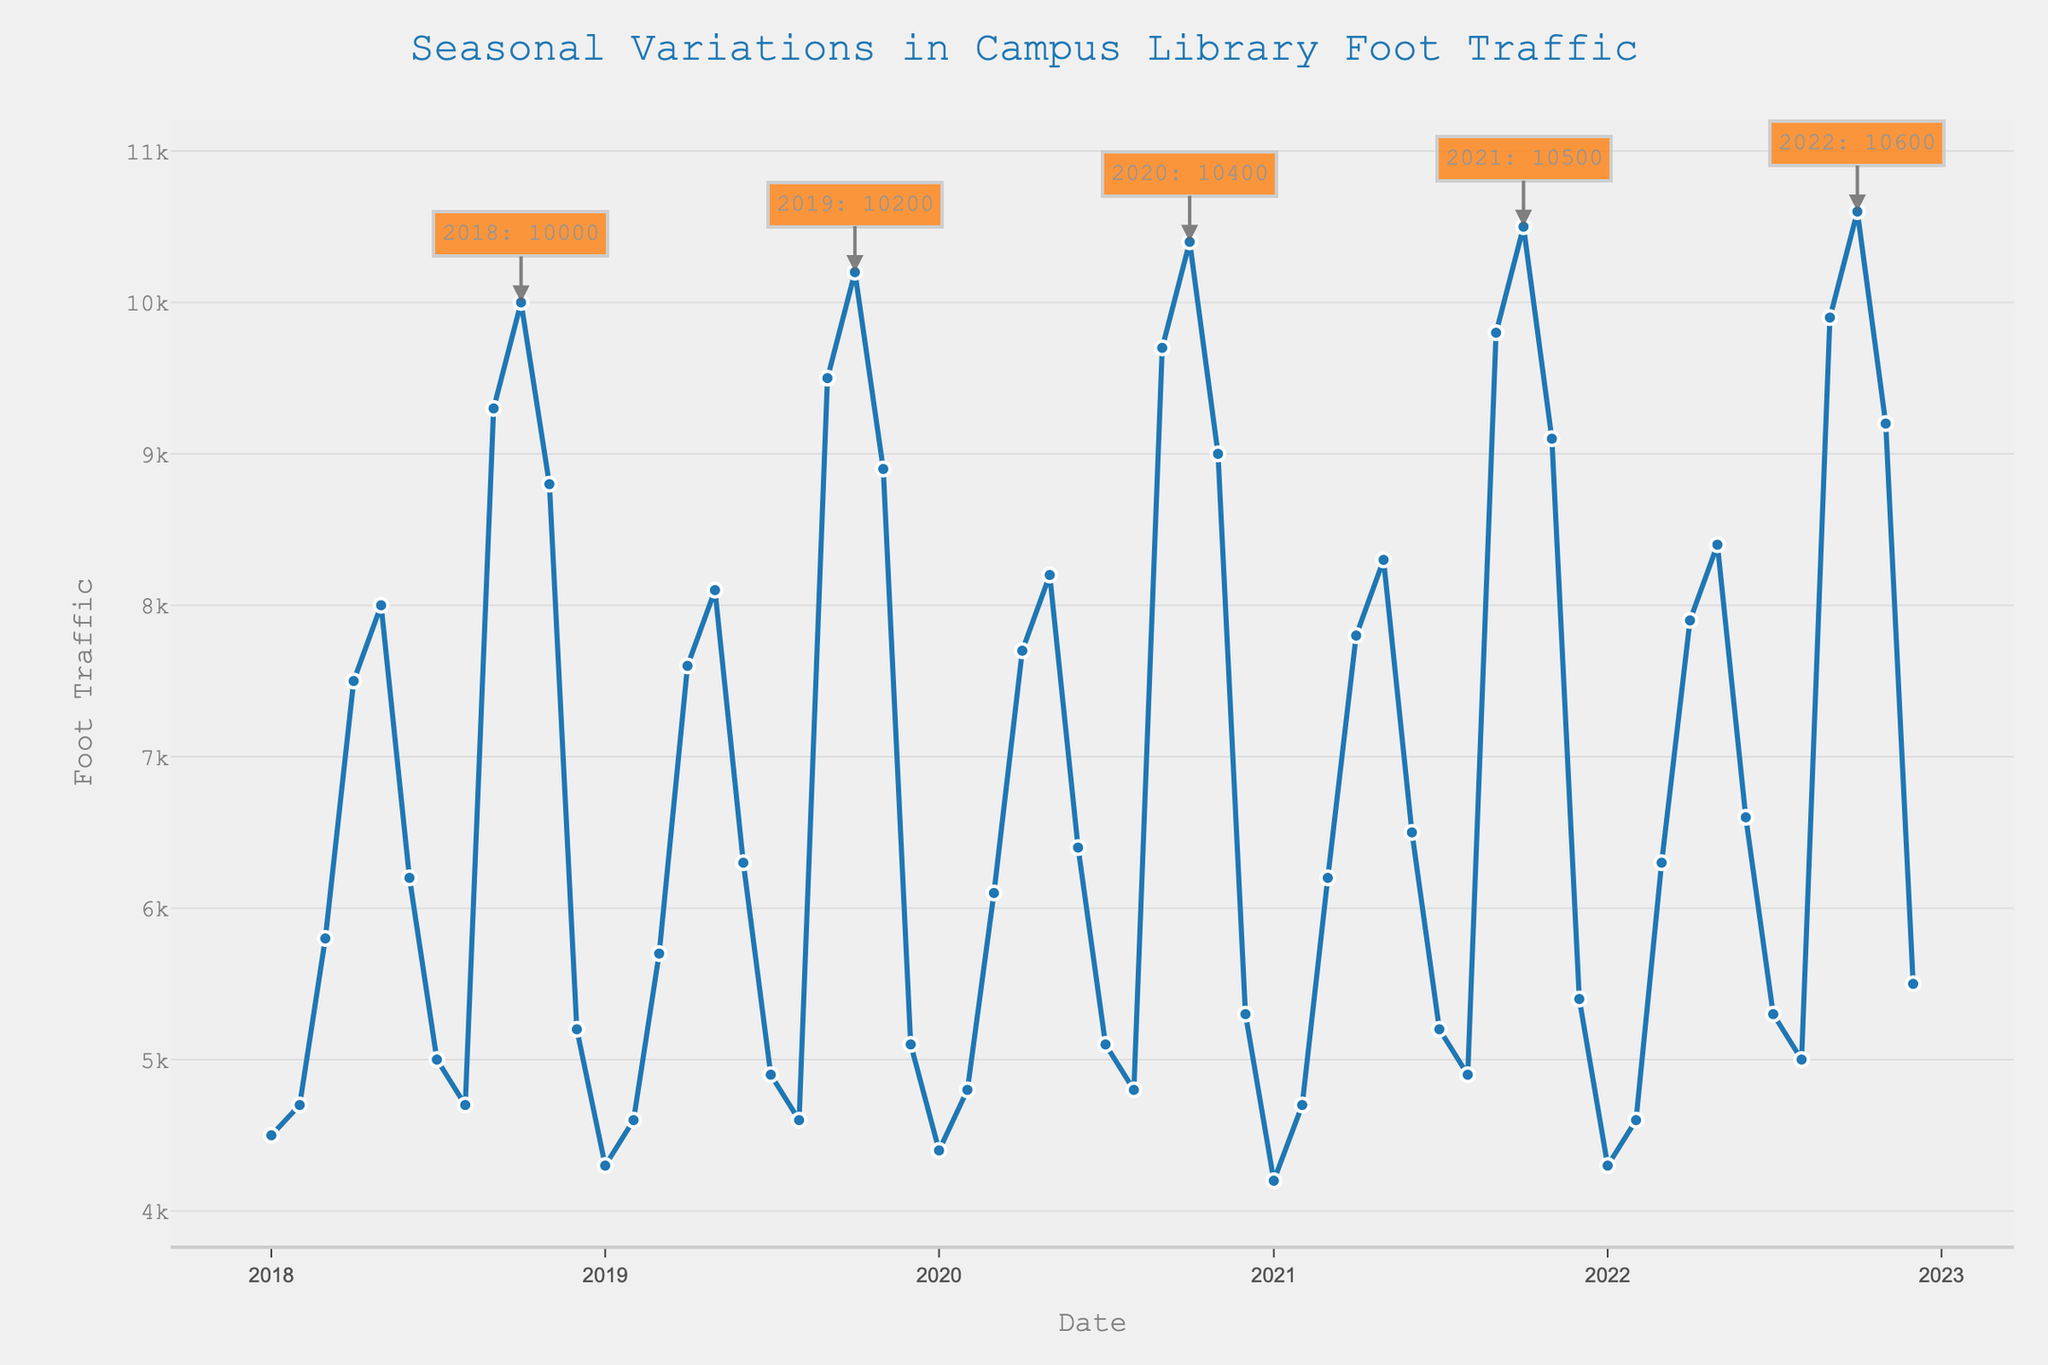What is the title of the plot? The title is usually located at the top of the plot. In this case, it reads "Seasonal Variations in Campus Library Foot Traffic"
Answer: Seasonal Variations in Campus Library Foot Traffic What is the y-axis labeled as? The y-axis label is typically found along the left side of the plot, indicating the measurement being displayed. Here, it is labeled as "Foot Traffic"
Answer: Foot Traffic During which month and year did the campus library see the highest foot traffic? To find the peak foot traffic, look for the highest point on the plot. The annotations also help identify the peak values for each year. The highest point appears in October 2022
Answer: October 2022 What was the foot traffic in March 2020? Locate the date on the x-axis for March 2020 and read the corresponding value on the y-axis. The foot traffic for March 2020 is slightly above 6000
Answer: 6100 How does the foot traffic in April 2019 compare to April 2020? Find the points for April 2019 and April 2020 on the plot and compare their y-axis values. April 2019 shows 7600 while April 2020 shows 7700, indicating a slight increase in 2020
Answer: 7700 is slightly higher than 7600 What trend can be seen in foot traffic from January to May each year? Examine the plot from January to May for each year. The trend shows steadily increasing foot traffic during these months each year
Answer: Foot traffic increases What is the difference in foot traffic between the highest and lowest months in 2018? Identify the highest and lowest foot traffic points for 2018 using the plot or annotations. October 2018 has the highest at 10,000 and January 2018 has the lowest at 4,500. Calculate the difference 10,000 - 4,500
Answer: 5,500 What is the general pattern of foot traffic in December over the years? Look for the points in each December on the plot. Each December shows a lower value relative to the other months, indicating a seasonal decrease in foot traffic
Answer: Decreases Which year had the most consistent level of foot traffic throughout the months? To find the most consistent year, observe the fluctuations in each year's data points individually. The year 2018 shows relatively larger fluctuations, whereas 2020 shows fewer extreme changes
Answer: 2020 How many major seasonal peaks are there in the plot? Major seasonal peaks are typically the highest points within each year. Viewing the plot, there is one major peak per year, totaling 5 peaks for 2018 to 2022
Answer: 5 